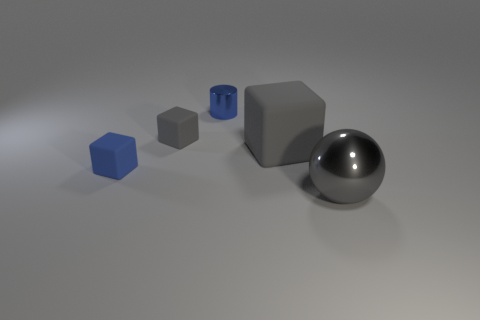Subtract 1 blocks. How many blocks are left? 2 Add 1 brown matte cubes. How many objects exist? 6 Subtract all cubes. How many objects are left? 2 Subtract all big red balls. Subtract all tiny blue things. How many objects are left? 3 Add 3 large blocks. How many large blocks are left? 4 Add 4 small blue cubes. How many small blue cubes exist? 5 Subtract 0 red cylinders. How many objects are left? 5 